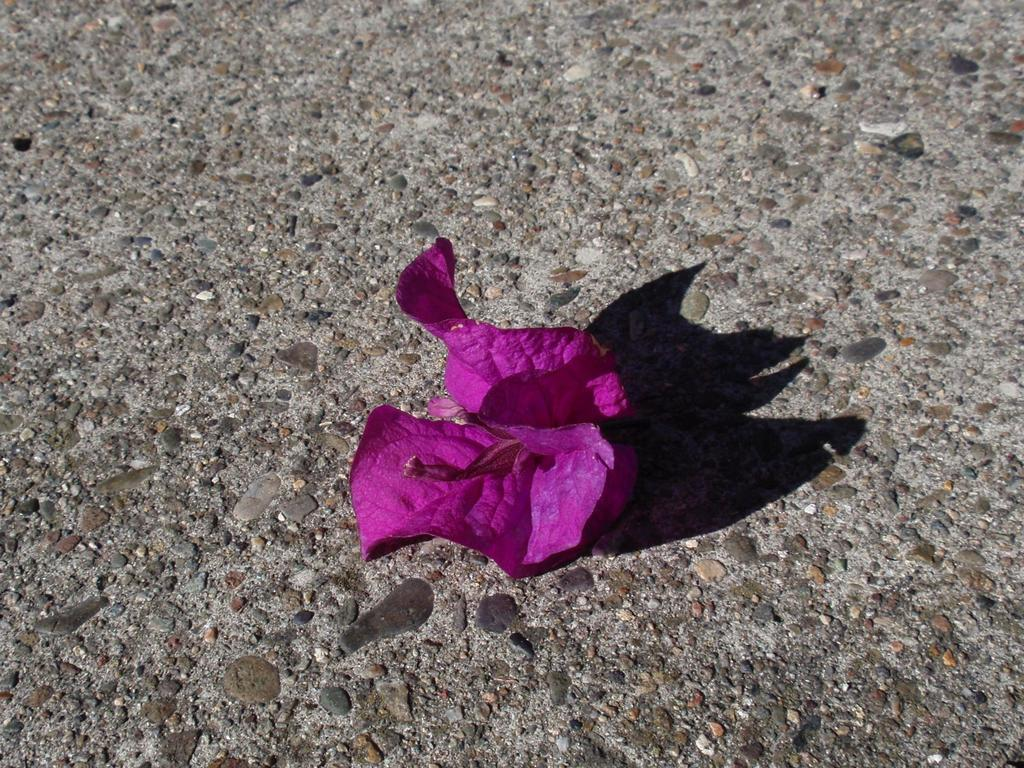What type of flower is in the image? There is a pink flower in the image. Where is the pink flower located? The pink flower is on a surface. What sign is the pink flower holding in the image? There is no sign present in the image, and the pink flower is not holding anything. 